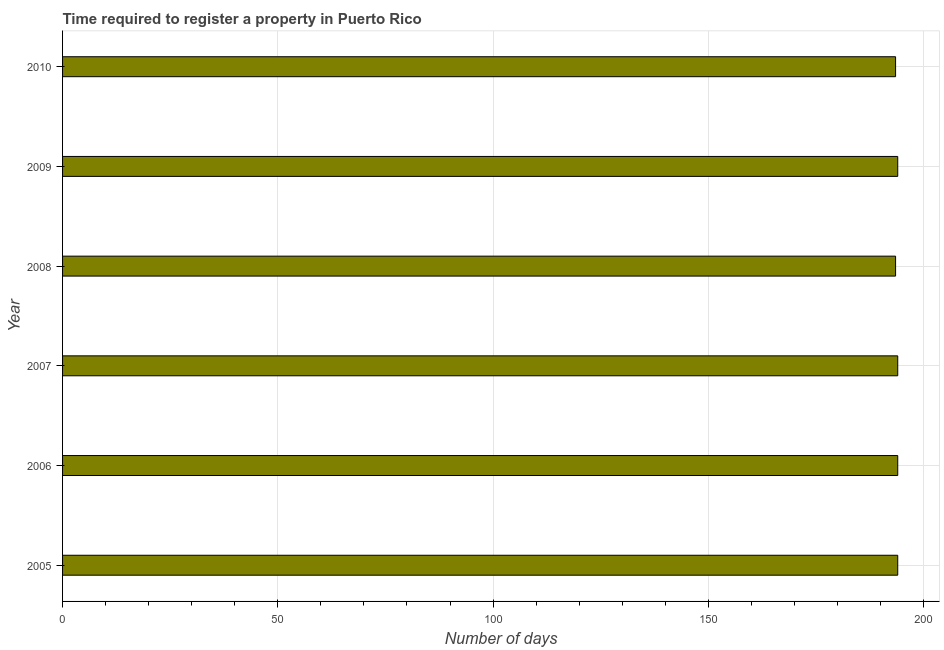Does the graph contain grids?
Offer a very short reply. Yes. What is the title of the graph?
Offer a very short reply. Time required to register a property in Puerto Rico. What is the label or title of the X-axis?
Your answer should be very brief. Number of days. What is the number of days required to register property in 2005?
Your response must be concise. 194. Across all years, what is the maximum number of days required to register property?
Provide a succinct answer. 194. Across all years, what is the minimum number of days required to register property?
Keep it short and to the point. 193.5. In which year was the number of days required to register property maximum?
Provide a succinct answer. 2005. In which year was the number of days required to register property minimum?
Provide a succinct answer. 2008. What is the sum of the number of days required to register property?
Ensure brevity in your answer.  1163. What is the average number of days required to register property per year?
Give a very brief answer. 193.83. What is the median number of days required to register property?
Your response must be concise. 194. Do a majority of the years between 2007 and 2010 (inclusive) have number of days required to register property greater than 180 days?
Provide a short and direct response. Yes. What is the difference between the highest and the second highest number of days required to register property?
Offer a terse response. 0. What is the difference between the highest and the lowest number of days required to register property?
Ensure brevity in your answer.  0.5. In how many years, is the number of days required to register property greater than the average number of days required to register property taken over all years?
Offer a terse response. 4. What is the Number of days of 2005?
Offer a terse response. 194. What is the Number of days of 2006?
Your answer should be very brief. 194. What is the Number of days of 2007?
Give a very brief answer. 194. What is the Number of days in 2008?
Your response must be concise. 193.5. What is the Number of days of 2009?
Provide a short and direct response. 194. What is the Number of days in 2010?
Provide a short and direct response. 193.5. What is the difference between the Number of days in 2005 and 2008?
Provide a short and direct response. 0.5. What is the difference between the Number of days in 2005 and 2010?
Your answer should be compact. 0.5. What is the difference between the Number of days in 2006 and 2008?
Provide a succinct answer. 0.5. What is the difference between the Number of days in 2006 and 2009?
Your answer should be very brief. 0. What is the difference between the Number of days in 2007 and 2008?
Your response must be concise. 0.5. What is the difference between the Number of days in 2007 and 2009?
Offer a terse response. 0. What is the difference between the Number of days in 2007 and 2010?
Ensure brevity in your answer.  0.5. What is the difference between the Number of days in 2008 and 2009?
Give a very brief answer. -0.5. What is the difference between the Number of days in 2008 and 2010?
Your response must be concise. 0. What is the ratio of the Number of days in 2005 to that in 2006?
Your answer should be compact. 1. What is the ratio of the Number of days in 2005 to that in 2007?
Your response must be concise. 1. What is the ratio of the Number of days in 2005 to that in 2009?
Ensure brevity in your answer.  1. What is the ratio of the Number of days in 2005 to that in 2010?
Offer a very short reply. 1. What is the ratio of the Number of days in 2006 to that in 2009?
Provide a short and direct response. 1. What is the ratio of the Number of days in 2007 to that in 2009?
Give a very brief answer. 1. What is the ratio of the Number of days in 2008 to that in 2010?
Make the answer very short. 1. What is the ratio of the Number of days in 2009 to that in 2010?
Keep it short and to the point. 1. 